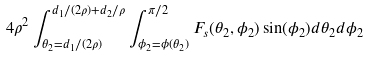Convert formula to latex. <formula><loc_0><loc_0><loc_500><loc_500>4 \rho ^ { 2 } \int _ { \theta _ { 2 } = d _ { 1 } / ( 2 \rho ) } ^ { d _ { 1 } / ( 2 \rho ) + d _ { 2 } / \rho } \int _ { \phi _ { 2 } = \phi ( \theta _ { 2 } ) } ^ { \pi / 2 } F _ { s } ( \theta _ { 2 } , \phi _ { 2 } ) \sin ( \phi _ { 2 } ) d \theta _ { 2 } d \phi _ { 2 }</formula> 